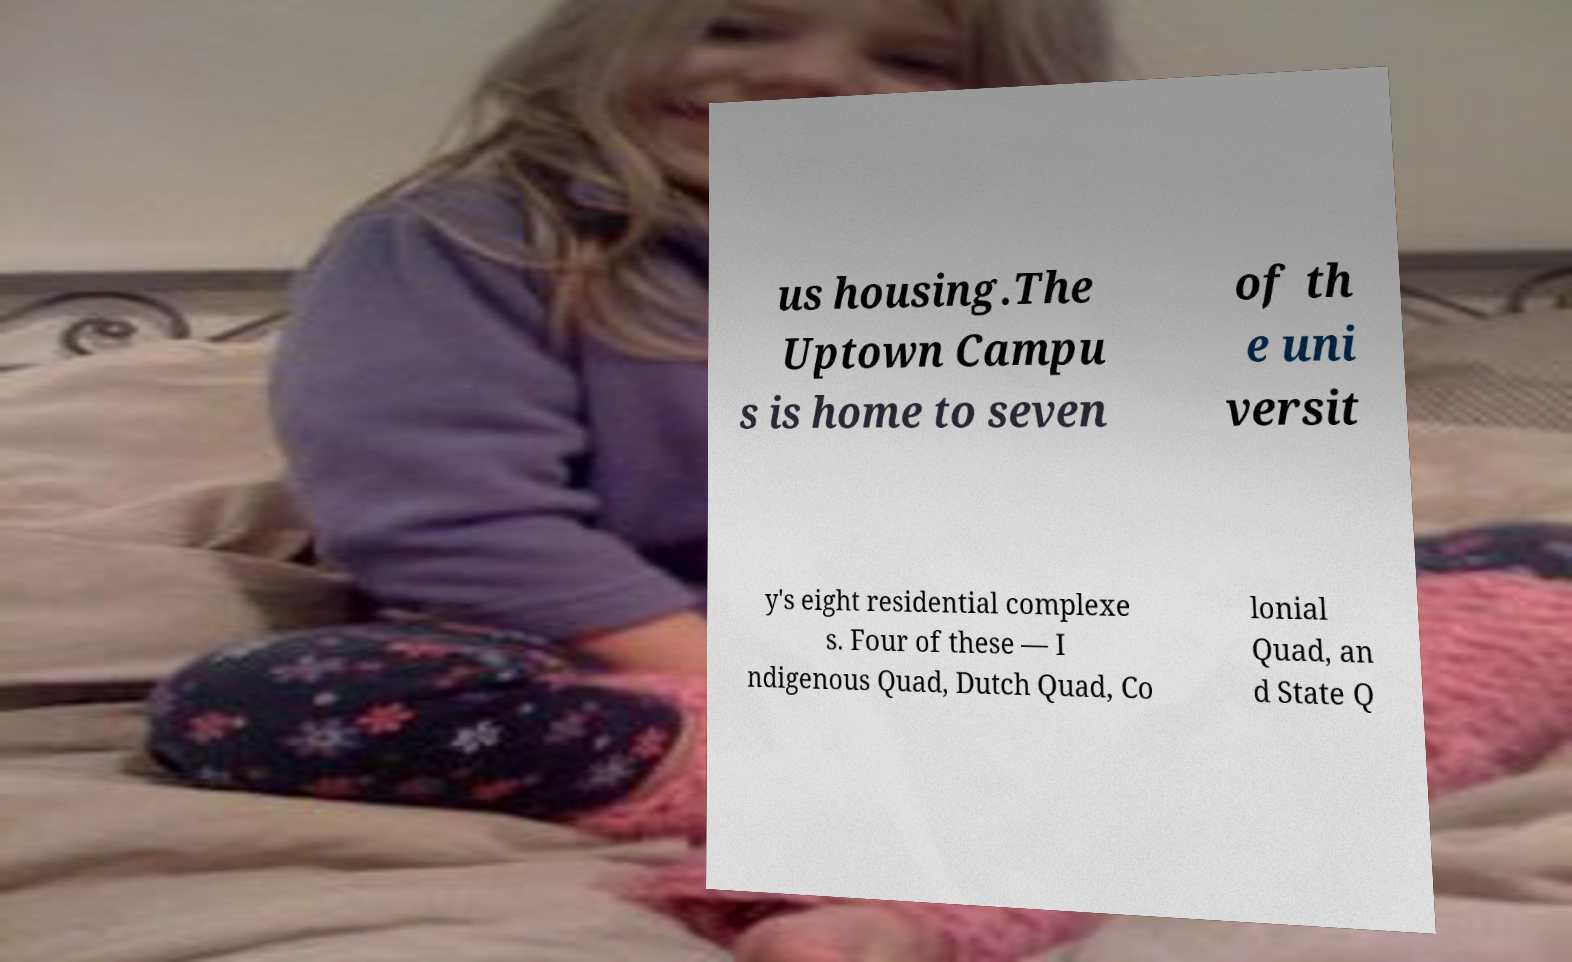I need the written content from this picture converted into text. Can you do that? us housing.The Uptown Campu s is home to seven of th e uni versit y's eight residential complexe s. Four of these — I ndigenous Quad, Dutch Quad, Co lonial Quad, an d State Q 